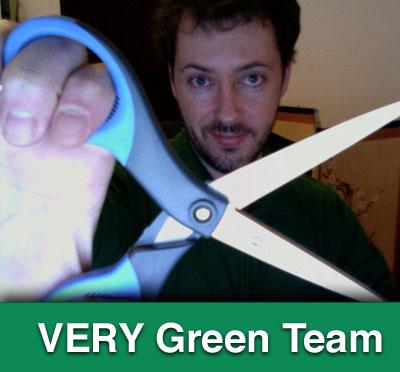What is the gentlemen holding?
Be succinct. Scissors. What do they mean by "Green"?
Keep it brief. Environmentally friendly. Is the man smiling?
Be succinct. Yes. 